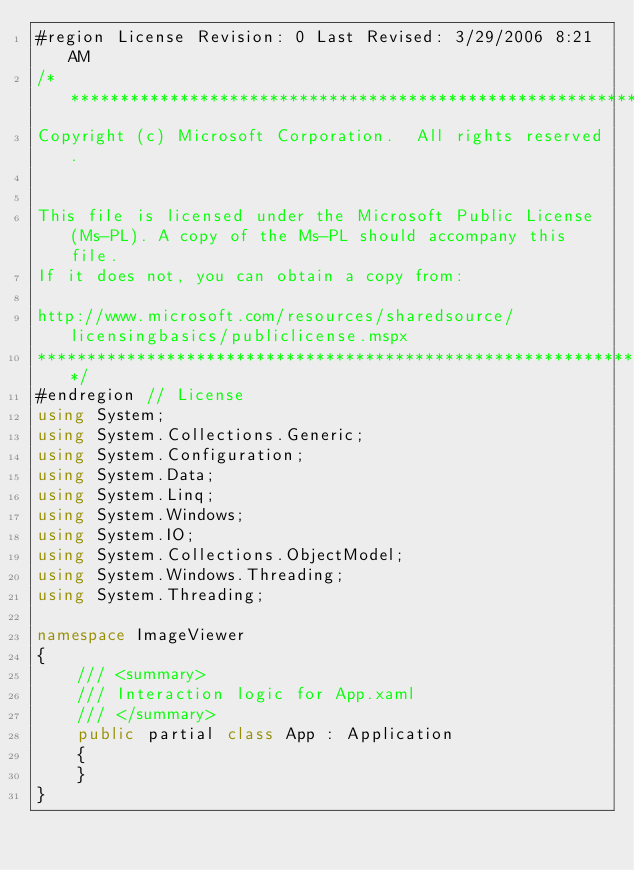Convert code to text. <code><loc_0><loc_0><loc_500><loc_500><_C#_>#region License Revision: 0 Last Revised: 3/29/2006 8:21 AM
/******************************************************************************
Copyright (c) Microsoft Corporation.  All rights reserved.


This file is licensed under the Microsoft Public License (Ms-PL). A copy of the Ms-PL should accompany this file. 
If it does not, you can obtain a copy from: 

http://www.microsoft.com/resources/sharedsource/licensingbasics/publiclicense.mspx
******************************************************************************/
#endregion // License
using System;
using System.Collections.Generic;
using System.Configuration;
using System.Data;
using System.Linq;
using System.Windows;
using System.IO;
using System.Collections.ObjectModel;
using System.Windows.Threading;
using System.Threading;

namespace ImageViewer
{
    /// <summary>
    /// Interaction logic for App.xaml
    /// </summary>
    public partial class App : Application
    {
    }
}
</code> 